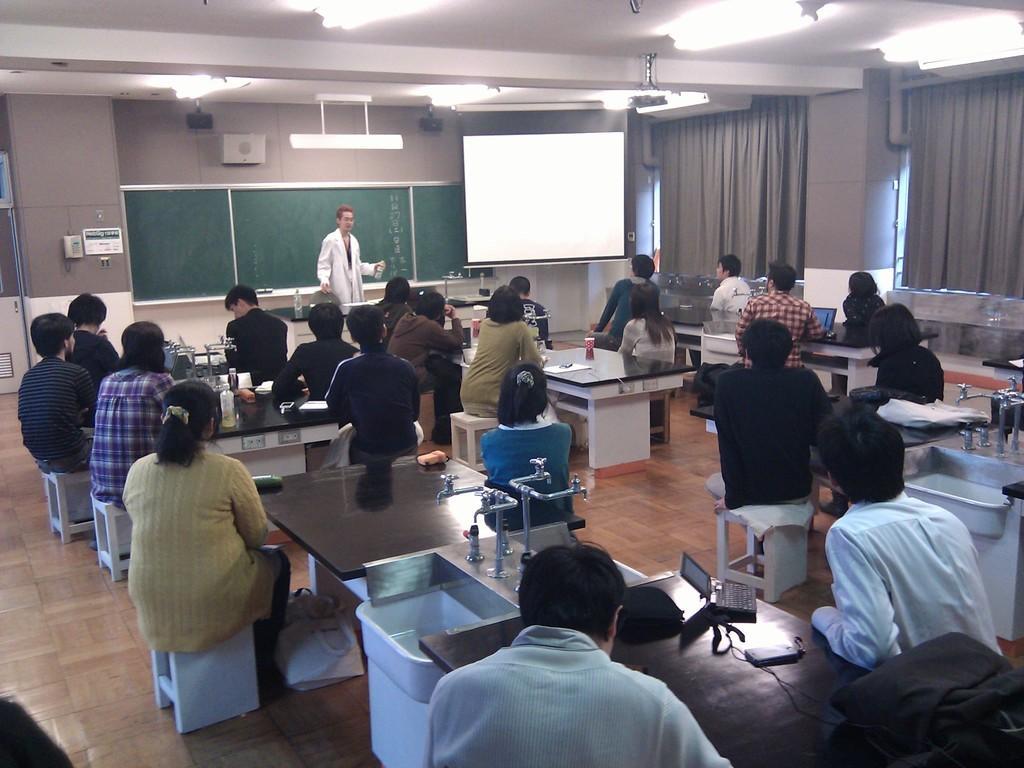How would you summarize this image in a sentence or two? This picture is taken inside a laboratory. In this image, we can see a group of people sitting on the chair in front of the table. On that table, we can see some water taps, bottles, laptops. In the middle of the image, we can see a person standing. In the background, we can see a wall and a screen and some electronic instrument. At the top, we can see a roof with few lights. 